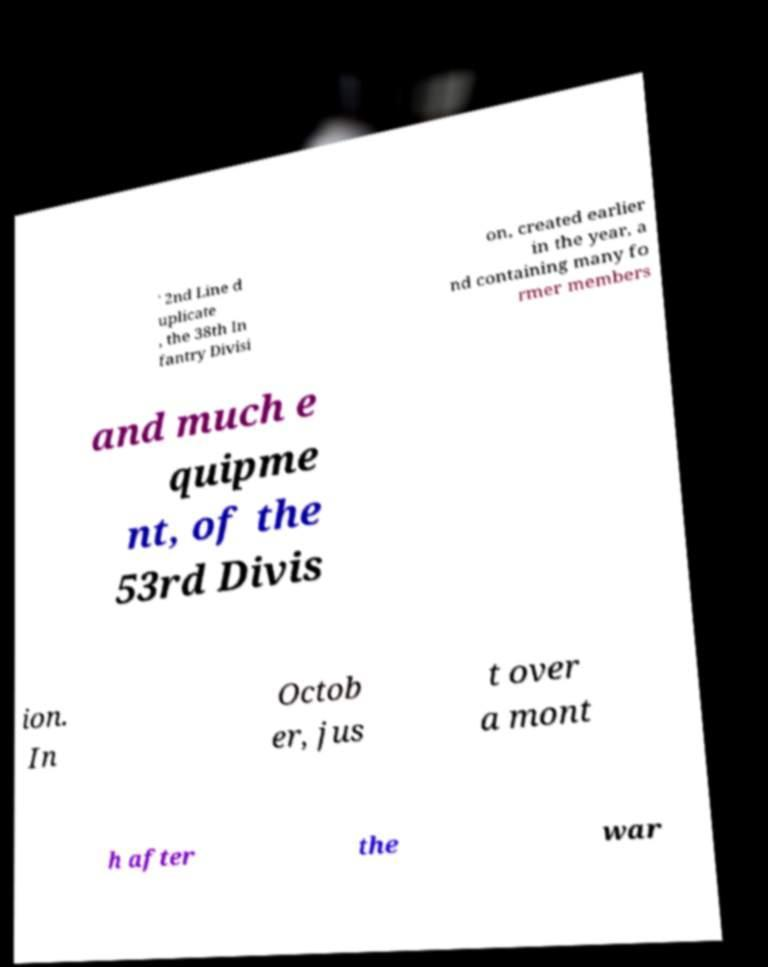Can you read and provide the text displayed in the image?This photo seems to have some interesting text. Can you extract and type it out for me? ' 2nd Line d uplicate , the 38th In fantry Divisi on, created earlier in the year, a nd containing many fo rmer members and much e quipme nt, of the 53rd Divis ion. In Octob er, jus t over a mont h after the war 